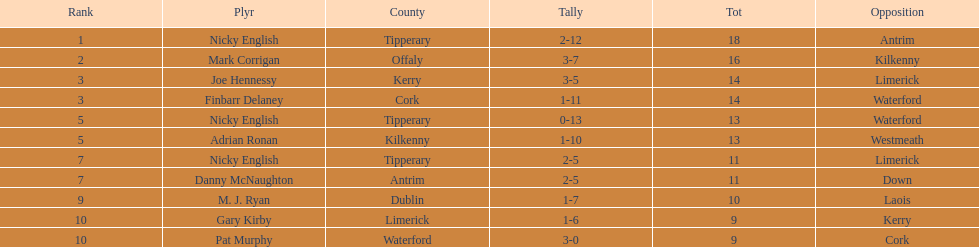What was the combined total of nicky english and mark corrigan? 34. 